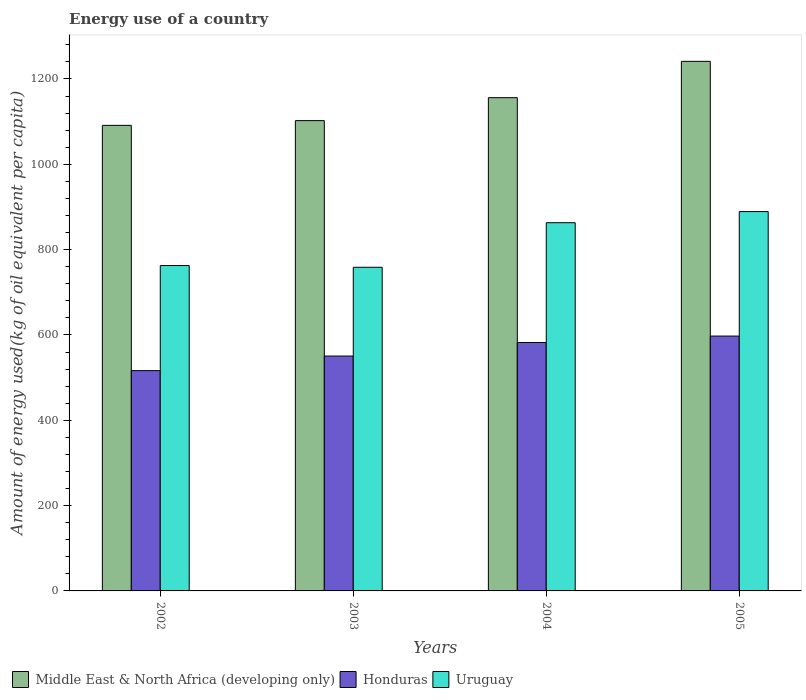How many groups of bars are there?
Ensure brevity in your answer.  4. Are the number of bars per tick equal to the number of legend labels?
Provide a short and direct response. Yes. How many bars are there on the 1st tick from the left?
Provide a short and direct response. 3. What is the label of the 3rd group of bars from the left?
Give a very brief answer. 2004. What is the amount of energy used in in Middle East & North Africa (developing only) in 2003?
Offer a very short reply. 1102.41. Across all years, what is the maximum amount of energy used in in Middle East & North Africa (developing only)?
Offer a very short reply. 1241.33. Across all years, what is the minimum amount of energy used in in Middle East & North Africa (developing only)?
Your answer should be compact. 1091.27. In which year was the amount of energy used in in Honduras maximum?
Your response must be concise. 2005. What is the total amount of energy used in in Middle East & North Africa (developing only) in the graph?
Offer a very short reply. 4591.25. What is the difference between the amount of energy used in in Middle East & North Africa (developing only) in 2002 and that in 2003?
Ensure brevity in your answer.  -11.14. What is the difference between the amount of energy used in in Uruguay in 2002 and the amount of energy used in in Honduras in 2004?
Provide a short and direct response. 180.44. What is the average amount of energy used in in Uruguay per year?
Offer a terse response. 818.41. In the year 2002, what is the difference between the amount of energy used in in Honduras and amount of energy used in in Middle East & North Africa (developing only)?
Offer a very short reply. -574.87. In how many years, is the amount of energy used in in Honduras greater than 520 kg?
Provide a short and direct response. 3. What is the ratio of the amount of energy used in in Honduras in 2004 to that in 2005?
Your answer should be very brief. 0.97. Is the difference between the amount of energy used in in Honduras in 2003 and 2005 greater than the difference between the amount of energy used in in Middle East & North Africa (developing only) in 2003 and 2005?
Ensure brevity in your answer.  Yes. What is the difference between the highest and the second highest amount of energy used in in Uruguay?
Your answer should be very brief. 26.11. What is the difference between the highest and the lowest amount of energy used in in Uruguay?
Your response must be concise. 130.56. In how many years, is the amount of energy used in in Uruguay greater than the average amount of energy used in in Uruguay taken over all years?
Keep it short and to the point. 2. Is the sum of the amount of energy used in in Uruguay in 2002 and 2003 greater than the maximum amount of energy used in in Honduras across all years?
Provide a short and direct response. Yes. What does the 2nd bar from the left in 2003 represents?
Ensure brevity in your answer.  Honduras. What does the 1st bar from the right in 2005 represents?
Ensure brevity in your answer.  Uruguay. Is it the case that in every year, the sum of the amount of energy used in in Uruguay and amount of energy used in in Middle East & North Africa (developing only) is greater than the amount of energy used in in Honduras?
Keep it short and to the point. Yes. How many bars are there?
Offer a very short reply. 12. What is the difference between two consecutive major ticks on the Y-axis?
Ensure brevity in your answer.  200. Are the values on the major ticks of Y-axis written in scientific E-notation?
Provide a short and direct response. No. Does the graph contain any zero values?
Your answer should be compact. No. How many legend labels are there?
Your answer should be compact. 3. How are the legend labels stacked?
Your answer should be compact. Horizontal. What is the title of the graph?
Your answer should be very brief. Energy use of a country. Does "Japan" appear as one of the legend labels in the graph?
Give a very brief answer. No. What is the label or title of the X-axis?
Offer a very short reply. Years. What is the label or title of the Y-axis?
Provide a short and direct response. Amount of energy used(kg of oil equivalent per capita). What is the Amount of energy used(kg of oil equivalent per capita) of Middle East & North Africa (developing only) in 2002?
Your answer should be compact. 1091.27. What is the Amount of energy used(kg of oil equivalent per capita) in Honduras in 2002?
Ensure brevity in your answer.  516.4. What is the Amount of energy used(kg of oil equivalent per capita) in Uruguay in 2002?
Your response must be concise. 762.7. What is the Amount of energy used(kg of oil equivalent per capita) of Middle East & North Africa (developing only) in 2003?
Provide a short and direct response. 1102.41. What is the Amount of energy used(kg of oil equivalent per capita) in Honduras in 2003?
Make the answer very short. 550.56. What is the Amount of energy used(kg of oil equivalent per capita) in Uruguay in 2003?
Your answer should be compact. 758.65. What is the Amount of energy used(kg of oil equivalent per capita) of Middle East & North Africa (developing only) in 2004?
Offer a terse response. 1156.23. What is the Amount of energy used(kg of oil equivalent per capita) of Honduras in 2004?
Your response must be concise. 582.26. What is the Amount of energy used(kg of oil equivalent per capita) in Uruguay in 2004?
Keep it short and to the point. 863.1. What is the Amount of energy used(kg of oil equivalent per capita) in Middle East & North Africa (developing only) in 2005?
Offer a terse response. 1241.33. What is the Amount of energy used(kg of oil equivalent per capita) in Honduras in 2005?
Offer a very short reply. 597.36. What is the Amount of energy used(kg of oil equivalent per capita) in Uruguay in 2005?
Provide a succinct answer. 889.21. Across all years, what is the maximum Amount of energy used(kg of oil equivalent per capita) in Middle East & North Africa (developing only)?
Your answer should be very brief. 1241.33. Across all years, what is the maximum Amount of energy used(kg of oil equivalent per capita) of Honduras?
Make the answer very short. 597.36. Across all years, what is the maximum Amount of energy used(kg of oil equivalent per capita) of Uruguay?
Your answer should be very brief. 889.21. Across all years, what is the minimum Amount of energy used(kg of oil equivalent per capita) of Middle East & North Africa (developing only)?
Your response must be concise. 1091.27. Across all years, what is the minimum Amount of energy used(kg of oil equivalent per capita) in Honduras?
Your answer should be compact. 516.4. Across all years, what is the minimum Amount of energy used(kg of oil equivalent per capita) of Uruguay?
Give a very brief answer. 758.65. What is the total Amount of energy used(kg of oil equivalent per capita) of Middle East & North Africa (developing only) in the graph?
Offer a very short reply. 4591.25. What is the total Amount of energy used(kg of oil equivalent per capita) of Honduras in the graph?
Your response must be concise. 2246.58. What is the total Amount of energy used(kg of oil equivalent per capita) of Uruguay in the graph?
Your answer should be very brief. 3273.65. What is the difference between the Amount of energy used(kg of oil equivalent per capita) of Middle East & North Africa (developing only) in 2002 and that in 2003?
Offer a very short reply. -11.14. What is the difference between the Amount of energy used(kg of oil equivalent per capita) of Honduras in 2002 and that in 2003?
Offer a very short reply. -34.15. What is the difference between the Amount of energy used(kg of oil equivalent per capita) in Uruguay in 2002 and that in 2003?
Keep it short and to the point. 4.05. What is the difference between the Amount of energy used(kg of oil equivalent per capita) of Middle East & North Africa (developing only) in 2002 and that in 2004?
Your answer should be very brief. -64.96. What is the difference between the Amount of energy used(kg of oil equivalent per capita) of Honduras in 2002 and that in 2004?
Make the answer very short. -65.85. What is the difference between the Amount of energy used(kg of oil equivalent per capita) of Uruguay in 2002 and that in 2004?
Ensure brevity in your answer.  -100.4. What is the difference between the Amount of energy used(kg of oil equivalent per capita) of Middle East & North Africa (developing only) in 2002 and that in 2005?
Your answer should be compact. -150.06. What is the difference between the Amount of energy used(kg of oil equivalent per capita) of Honduras in 2002 and that in 2005?
Provide a succinct answer. -80.96. What is the difference between the Amount of energy used(kg of oil equivalent per capita) of Uruguay in 2002 and that in 2005?
Make the answer very short. -126.51. What is the difference between the Amount of energy used(kg of oil equivalent per capita) in Middle East & North Africa (developing only) in 2003 and that in 2004?
Provide a succinct answer. -53.82. What is the difference between the Amount of energy used(kg of oil equivalent per capita) of Honduras in 2003 and that in 2004?
Ensure brevity in your answer.  -31.7. What is the difference between the Amount of energy used(kg of oil equivalent per capita) of Uruguay in 2003 and that in 2004?
Your response must be concise. -104.46. What is the difference between the Amount of energy used(kg of oil equivalent per capita) in Middle East & North Africa (developing only) in 2003 and that in 2005?
Give a very brief answer. -138.92. What is the difference between the Amount of energy used(kg of oil equivalent per capita) in Honduras in 2003 and that in 2005?
Keep it short and to the point. -46.81. What is the difference between the Amount of energy used(kg of oil equivalent per capita) in Uruguay in 2003 and that in 2005?
Your answer should be very brief. -130.56. What is the difference between the Amount of energy used(kg of oil equivalent per capita) in Middle East & North Africa (developing only) in 2004 and that in 2005?
Give a very brief answer. -85.1. What is the difference between the Amount of energy used(kg of oil equivalent per capita) in Honduras in 2004 and that in 2005?
Give a very brief answer. -15.11. What is the difference between the Amount of energy used(kg of oil equivalent per capita) of Uruguay in 2004 and that in 2005?
Offer a very short reply. -26.11. What is the difference between the Amount of energy used(kg of oil equivalent per capita) in Middle East & North Africa (developing only) in 2002 and the Amount of energy used(kg of oil equivalent per capita) in Honduras in 2003?
Give a very brief answer. 540.72. What is the difference between the Amount of energy used(kg of oil equivalent per capita) in Middle East & North Africa (developing only) in 2002 and the Amount of energy used(kg of oil equivalent per capita) in Uruguay in 2003?
Your answer should be compact. 332.63. What is the difference between the Amount of energy used(kg of oil equivalent per capita) of Honduras in 2002 and the Amount of energy used(kg of oil equivalent per capita) of Uruguay in 2003?
Keep it short and to the point. -242.24. What is the difference between the Amount of energy used(kg of oil equivalent per capita) in Middle East & North Africa (developing only) in 2002 and the Amount of energy used(kg of oil equivalent per capita) in Honduras in 2004?
Your response must be concise. 509.02. What is the difference between the Amount of energy used(kg of oil equivalent per capita) of Middle East & North Africa (developing only) in 2002 and the Amount of energy used(kg of oil equivalent per capita) of Uruguay in 2004?
Provide a short and direct response. 228.17. What is the difference between the Amount of energy used(kg of oil equivalent per capita) of Honduras in 2002 and the Amount of energy used(kg of oil equivalent per capita) of Uruguay in 2004?
Your answer should be very brief. -346.7. What is the difference between the Amount of energy used(kg of oil equivalent per capita) in Middle East & North Africa (developing only) in 2002 and the Amount of energy used(kg of oil equivalent per capita) in Honduras in 2005?
Your answer should be very brief. 493.91. What is the difference between the Amount of energy used(kg of oil equivalent per capita) of Middle East & North Africa (developing only) in 2002 and the Amount of energy used(kg of oil equivalent per capita) of Uruguay in 2005?
Your answer should be very brief. 202.07. What is the difference between the Amount of energy used(kg of oil equivalent per capita) of Honduras in 2002 and the Amount of energy used(kg of oil equivalent per capita) of Uruguay in 2005?
Provide a short and direct response. -372.8. What is the difference between the Amount of energy used(kg of oil equivalent per capita) of Middle East & North Africa (developing only) in 2003 and the Amount of energy used(kg of oil equivalent per capita) of Honduras in 2004?
Offer a very short reply. 520.16. What is the difference between the Amount of energy used(kg of oil equivalent per capita) in Middle East & North Africa (developing only) in 2003 and the Amount of energy used(kg of oil equivalent per capita) in Uruguay in 2004?
Make the answer very short. 239.31. What is the difference between the Amount of energy used(kg of oil equivalent per capita) of Honduras in 2003 and the Amount of energy used(kg of oil equivalent per capita) of Uruguay in 2004?
Provide a short and direct response. -312.54. What is the difference between the Amount of energy used(kg of oil equivalent per capita) of Middle East & North Africa (developing only) in 2003 and the Amount of energy used(kg of oil equivalent per capita) of Honduras in 2005?
Keep it short and to the point. 505.05. What is the difference between the Amount of energy used(kg of oil equivalent per capita) in Middle East & North Africa (developing only) in 2003 and the Amount of energy used(kg of oil equivalent per capita) in Uruguay in 2005?
Your answer should be compact. 213.21. What is the difference between the Amount of energy used(kg of oil equivalent per capita) of Honduras in 2003 and the Amount of energy used(kg of oil equivalent per capita) of Uruguay in 2005?
Ensure brevity in your answer.  -338.65. What is the difference between the Amount of energy used(kg of oil equivalent per capita) of Middle East & North Africa (developing only) in 2004 and the Amount of energy used(kg of oil equivalent per capita) of Honduras in 2005?
Your response must be concise. 558.87. What is the difference between the Amount of energy used(kg of oil equivalent per capita) in Middle East & North Africa (developing only) in 2004 and the Amount of energy used(kg of oil equivalent per capita) in Uruguay in 2005?
Ensure brevity in your answer.  267.02. What is the difference between the Amount of energy used(kg of oil equivalent per capita) of Honduras in 2004 and the Amount of energy used(kg of oil equivalent per capita) of Uruguay in 2005?
Provide a short and direct response. -306.95. What is the average Amount of energy used(kg of oil equivalent per capita) in Middle East & North Africa (developing only) per year?
Your response must be concise. 1147.81. What is the average Amount of energy used(kg of oil equivalent per capita) of Honduras per year?
Your response must be concise. 561.65. What is the average Amount of energy used(kg of oil equivalent per capita) in Uruguay per year?
Make the answer very short. 818.41. In the year 2002, what is the difference between the Amount of energy used(kg of oil equivalent per capita) in Middle East & North Africa (developing only) and Amount of energy used(kg of oil equivalent per capita) in Honduras?
Provide a succinct answer. 574.87. In the year 2002, what is the difference between the Amount of energy used(kg of oil equivalent per capita) in Middle East & North Africa (developing only) and Amount of energy used(kg of oil equivalent per capita) in Uruguay?
Your response must be concise. 328.58. In the year 2002, what is the difference between the Amount of energy used(kg of oil equivalent per capita) of Honduras and Amount of energy used(kg of oil equivalent per capita) of Uruguay?
Offer a terse response. -246.29. In the year 2003, what is the difference between the Amount of energy used(kg of oil equivalent per capita) of Middle East & North Africa (developing only) and Amount of energy used(kg of oil equivalent per capita) of Honduras?
Keep it short and to the point. 551.86. In the year 2003, what is the difference between the Amount of energy used(kg of oil equivalent per capita) of Middle East & North Africa (developing only) and Amount of energy used(kg of oil equivalent per capita) of Uruguay?
Ensure brevity in your answer.  343.77. In the year 2003, what is the difference between the Amount of energy used(kg of oil equivalent per capita) in Honduras and Amount of energy used(kg of oil equivalent per capita) in Uruguay?
Your answer should be very brief. -208.09. In the year 2004, what is the difference between the Amount of energy used(kg of oil equivalent per capita) of Middle East & North Africa (developing only) and Amount of energy used(kg of oil equivalent per capita) of Honduras?
Offer a very short reply. 573.97. In the year 2004, what is the difference between the Amount of energy used(kg of oil equivalent per capita) of Middle East & North Africa (developing only) and Amount of energy used(kg of oil equivalent per capita) of Uruguay?
Keep it short and to the point. 293.13. In the year 2004, what is the difference between the Amount of energy used(kg of oil equivalent per capita) in Honduras and Amount of energy used(kg of oil equivalent per capita) in Uruguay?
Keep it short and to the point. -280.84. In the year 2005, what is the difference between the Amount of energy used(kg of oil equivalent per capita) in Middle East & North Africa (developing only) and Amount of energy used(kg of oil equivalent per capita) in Honduras?
Ensure brevity in your answer.  643.97. In the year 2005, what is the difference between the Amount of energy used(kg of oil equivalent per capita) in Middle East & North Africa (developing only) and Amount of energy used(kg of oil equivalent per capita) in Uruguay?
Keep it short and to the point. 352.12. In the year 2005, what is the difference between the Amount of energy used(kg of oil equivalent per capita) of Honduras and Amount of energy used(kg of oil equivalent per capita) of Uruguay?
Provide a short and direct response. -291.84. What is the ratio of the Amount of energy used(kg of oil equivalent per capita) of Honduras in 2002 to that in 2003?
Offer a terse response. 0.94. What is the ratio of the Amount of energy used(kg of oil equivalent per capita) of Uruguay in 2002 to that in 2003?
Ensure brevity in your answer.  1.01. What is the ratio of the Amount of energy used(kg of oil equivalent per capita) in Middle East & North Africa (developing only) in 2002 to that in 2004?
Your answer should be very brief. 0.94. What is the ratio of the Amount of energy used(kg of oil equivalent per capita) in Honduras in 2002 to that in 2004?
Give a very brief answer. 0.89. What is the ratio of the Amount of energy used(kg of oil equivalent per capita) of Uruguay in 2002 to that in 2004?
Make the answer very short. 0.88. What is the ratio of the Amount of energy used(kg of oil equivalent per capita) in Middle East & North Africa (developing only) in 2002 to that in 2005?
Provide a succinct answer. 0.88. What is the ratio of the Amount of energy used(kg of oil equivalent per capita) of Honduras in 2002 to that in 2005?
Keep it short and to the point. 0.86. What is the ratio of the Amount of energy used(kg of oil equivalent per capita) of Uruguay in 2002 to that in 2005?
Your answer should be compact. 0.86. What is the ratio of the Amount of energy used(kg of oil equivalent per capita) of Middle East & North Africa (developing only) in 2003 to that in 2004?
Your answer should be very brief. 0.95. What is the ratio of the Amount of energy used(kg of oil equivalent per capita) in Honduras in 2003 to that in 2004?
Ensure brevity in your answer.  0.95. What is the ratio of the Amount of energy used(kg of oil equivalent per capita) of Uruguay in 2003 to that in 2004?
Your answer should be very brief. 0.88. What is the ratio of the Amount of energy used(kg of oil equivalent per capita) in Middle East & North Africa (developing only) in 2003 to that in 2005?
Keep it short and to the point. 0.89. What is the ratio of the Amount of energy used(kg of oil equivalent per capita) in Honduras in 2003 to that in 2005?
Offer a terse response. 0.92. What is the ratio of the Amount of energy used(kg of oil equivalent per capita) of Uruguay in 2003 to that in 2005?
Provide a short and direct response. 0.85. What is the ratio of the Amount of energy used(kg of oil equivalent per capita) in Middle East & North Africa (developing only) in 2004 to that in 2005?
Offer a very short reply. 0.93. What is the ratio of the Amount of energy used(kg of oil equivalent per capita) of Honduras in 2004 to that in 2005?
Keep it short and to the point. 0.97. What is the ratio of the Amount of energy used(kg of oil equivalent per capita) of Uruguay in 2004 to that in 2005?
Provide a succinct answer. 0.97. What is the difference between the highest and the second highest Amount of energy used(kg of oil equivalent per capita) in Middle East & North Africa (developing only)?
Offer a terse response. 85.1. What is the difference between the highest and the second highest Amount of energy used(kg of oil equivalent per capita) of Honduras?
Your answer should be compact. 15.11. What is the difference between the highest and the second highest Amount of energy used(kg of oil equivalent per capita) in Uruguay?
Ensure brevity in your answer.  26.11. What is the difference between the highest and the lowest Amount of energy used(kg of oil equivalent per capita) in Middle East & North Africa (developing only)?
Give a very brief answer. 150.06. What is the difference between the highest and the lowest Amount of energy used(kg of oil equivalent per capita) of Honduras?
Offer a very short reply. 80.96. What is the difference between the highest and the lowest Amount of energy used(kg of oil equivalent per capita) in Uruguay?
Make the answer very short. 130.56. 